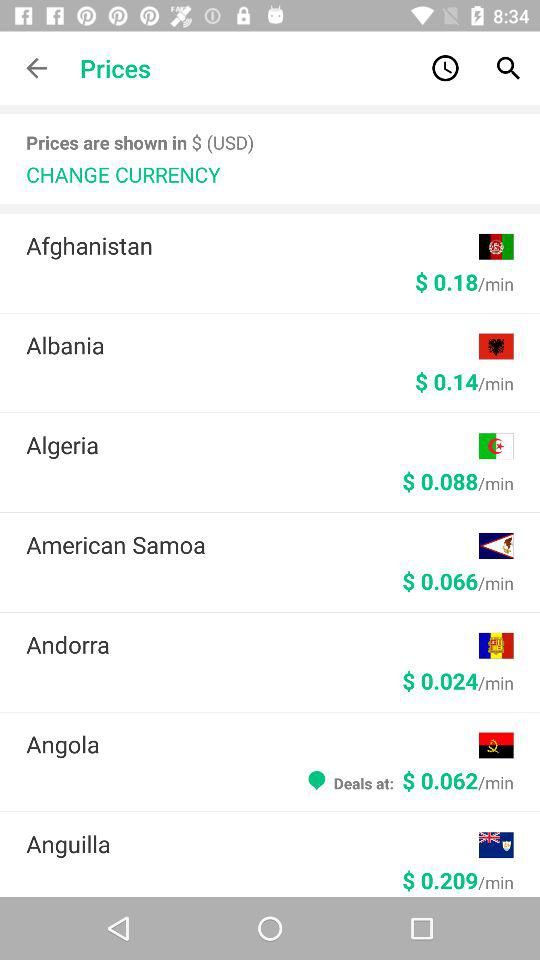How much does Angola cost per minute? The Angola cost per minute is $0.062. 